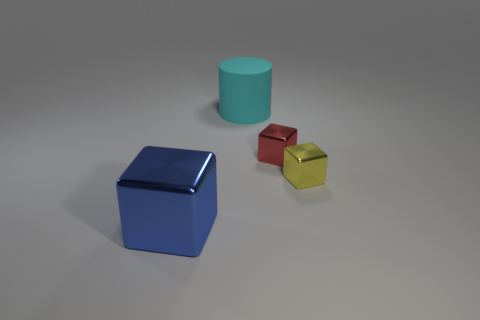Add 4 red shiny objects. How many objects exist? 8 Subtract all cylinders. How many objects are left? 3 Add 3 cubes. How many cubes are left? 6 Add 2 small red metal cylinders. How many small red metal cylinders exist? 2 Subtract 0 yellow spheres. How many objects are left? 4 Subtract all large cylinders. Subtract all large brown things. How many objects are left? 3 